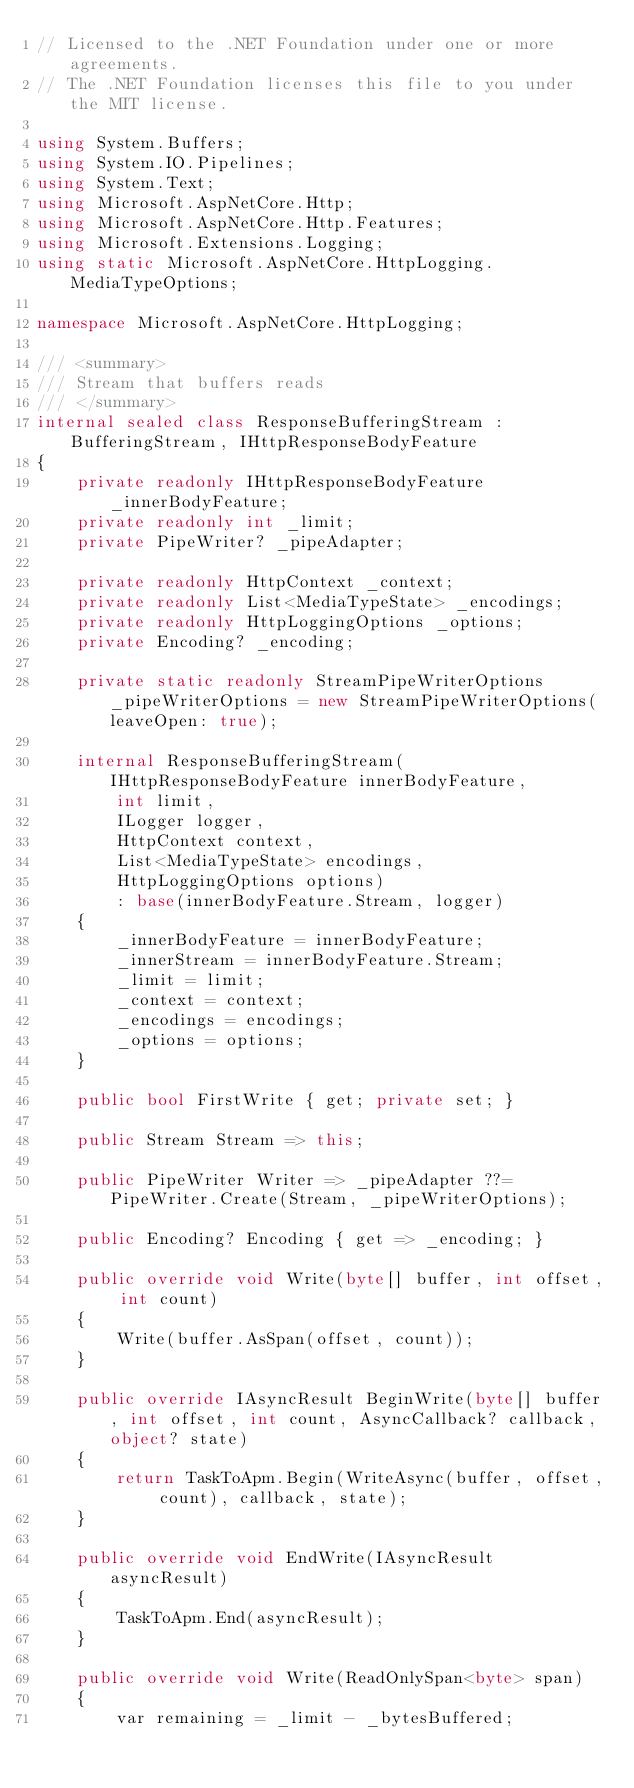Convert code to text. <code><loc_0><loc_0><loc_500><loc_500><_C#_>// Licensed to the .NET Foundation under one or more agreements.
// The .NET Foundation licenses this file to you under the MIT license.

using System.Buffers;
using System.IO.Pipelines;
using System.Text;
using Microsoft.AspNetCore.Http;
using Microsoft.AspNetCore.Http.Features;
using Microsoft.Extensions.Logging;
using static Microsoft.AspNetCore.HttpLogging.MediaTypeOptions;

namespace Microsoft.AspNetCore.HttpLogging;

/// <summary>
/// Stream that buffers reads
/// </summary>
internal sealed class ResponseBufferingStream : BufferingStream, IHttpResponseBodyFeature
{
    private readonly IHttpResponseBodyFeature _innerBodyFeature;
    private readonly int _limit;
    private PipeWriter? _pipeAdapter;

    private readonly HttpContext _context;
    private readonly List<MediaTypeState> _encodings;
    private readonly HttpLoggingOptions _options;
    private Encoding? _encoding;

    private static readonly StreamPipeWriterOptions _pipeWriterOptions = new StreamPipeWriterOptions(leaveOpen: true);

    internal ResponseBufferingStream(IHttpResponseBodyFeature innerBodyFeature,
        int limit,
        ILogger logger,
        HttpContext context,
        List<MediaTypeState> encodings,
        HttpLoggingOptions options)
        : base(innerBodyFeature.Stream, logger)
    {
        _innerBodyFeature = innerBodyFeature;
        _innerStream = innerBodyFeature.Stream;
        _limit = limit;
        _context = context;
        _encodings = encodings;
        _options = options;
    }

    public bool FirstWrite { get; private set; }

    public Stream Stream => this;

    public PipeWriter Writer => _pipeAdapter ??= PipeWriter.Create(Stream, _pipeWriterOptions);

    public Encoding? Encoding { get => _encoding; }

    public override void Write(byte[] buffer, int offset, int count)
    {
        Write(buffer.AsSpan(offset, count));
    }

    public override IAsyncResult BeginWrite(byte[] buffer, int offset, int count, AsyncCallback? callback, object? state)
    {
        return TaskToApm.Begin(WriteAsync(buffer, offset, count), callback, state);
    }

    public override void EndWrite(IAsyncResult asyncResult)
    {
        TaskToApm.End(asyncResult);
    }

    public override void Write(ReadOnlySpan<byte> span)
    {
        var remaining = _limit - _bytesBuffered;</code> 